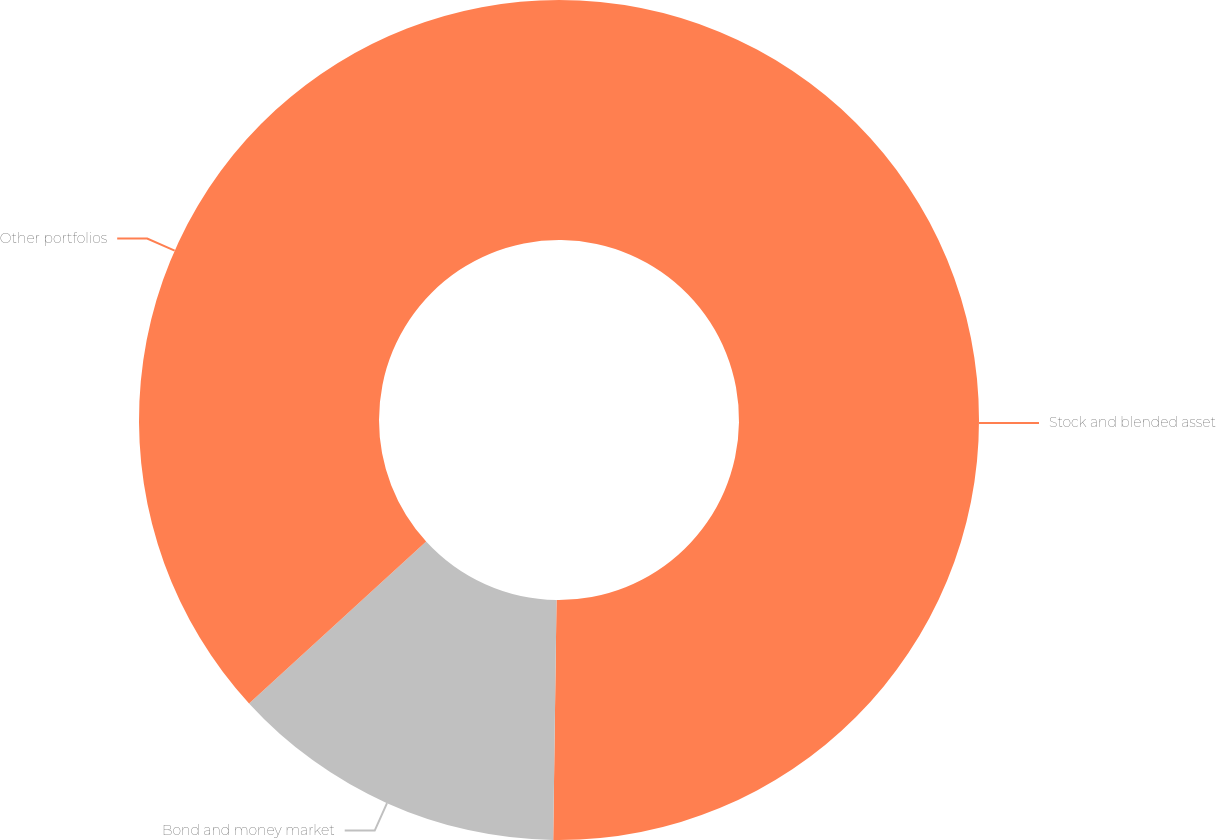<chart> <loc_0><loc_0><loc_500><loc_500><pie_chart><fcel>Stock and blended asset<fcel>Bond and money market<fcel>Other portfolios<nl><fcel>50.22%<fcel>12.99%<fcel>36.79%<nl></chart> 